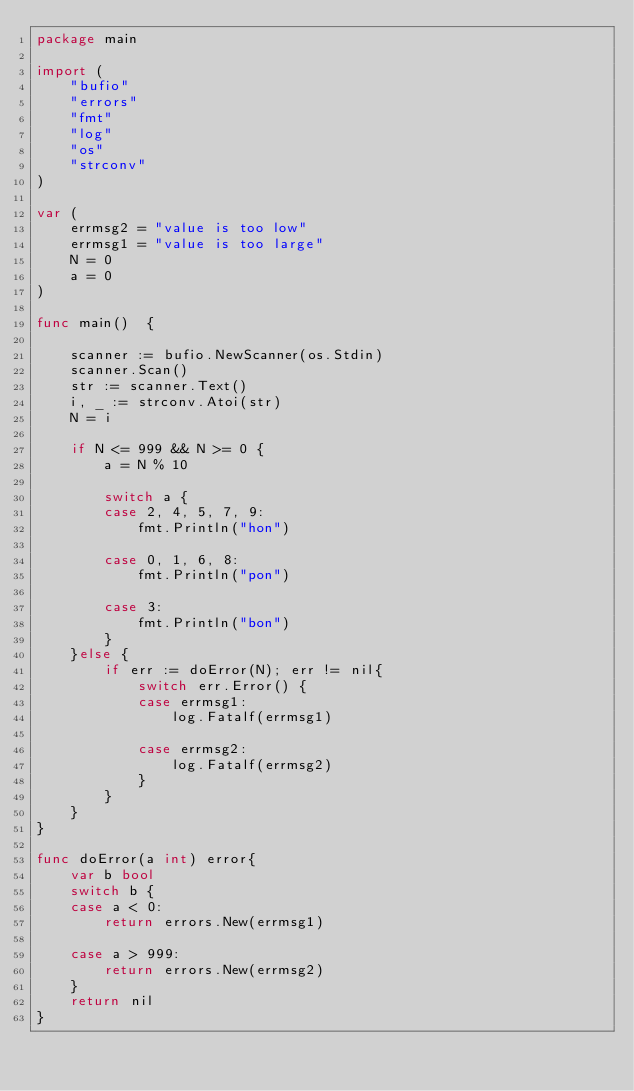Convert code to text. <code><loc_0><loc_0><loc_500><loc_500><_Go_>package main

import (
	"bufio"
	"errors"
	"fmt"
	"log"
	"os"
	"strconv"
)

var (
	errmsg2 = "value is too low"
	errmsg1 = "value is too large"
	N = 0
	a = 0
)

func main()  {

	scanner := bufio.NewScanner(os.Stdin)
	scanner.Scan()
	str := scanner.Text()
	i, _ := strconv.Atoi(str)
	N = i

	if N <= 999 && N >= 0 {
		a = N % 10

		switch a {
		case 2, 4, 5, 7, 9:
			fmt.Println("hon")

		case 0, 1, 6, 8:
			fmt.Println("pon")

		case 3:
			fmt.Println("bon")
		}
	}else {
		if err := doError(N); err != nil{
			switch err.Error() {
			case errmsg1:
				log.Fatalf(errmsg1)

			case errmsg2:
				log.Fatalf(errmsg2)
			}
		}
	}
}

func doError(a int) error{
	var b bool
	switch b {
	case a < 0:
		return errors.New(errmsg1)

	case a > 999:
		return errors.New(errmsg2)
	}
	return nil
}</code> 